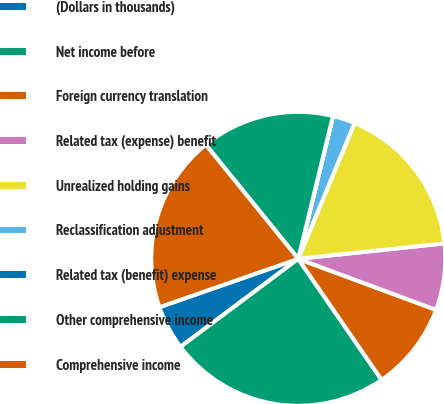<chart> <loc_0><loc_0><loc_500><loc_500><pie_chart><fcel>(Dollars in thousands)<fcel>Net income before<fcel>Foreign currency translation<fcel>Related tax (expense) benefit<fcel>Unrealized holding gains<fcel>Reclassification adjustment<fcel>Related tax (benefit) expense<fcel>Other comprehensive income<fcel>Comprehensive income<nl><fcel>4.88%<fcel>24.38%<fcel>9.76%<fcel>7.32%<fcel>17.07%<fcel>2.45%<fcel>0.01%<fcel>14.63%<fcel>19.5%<nl></chart> 